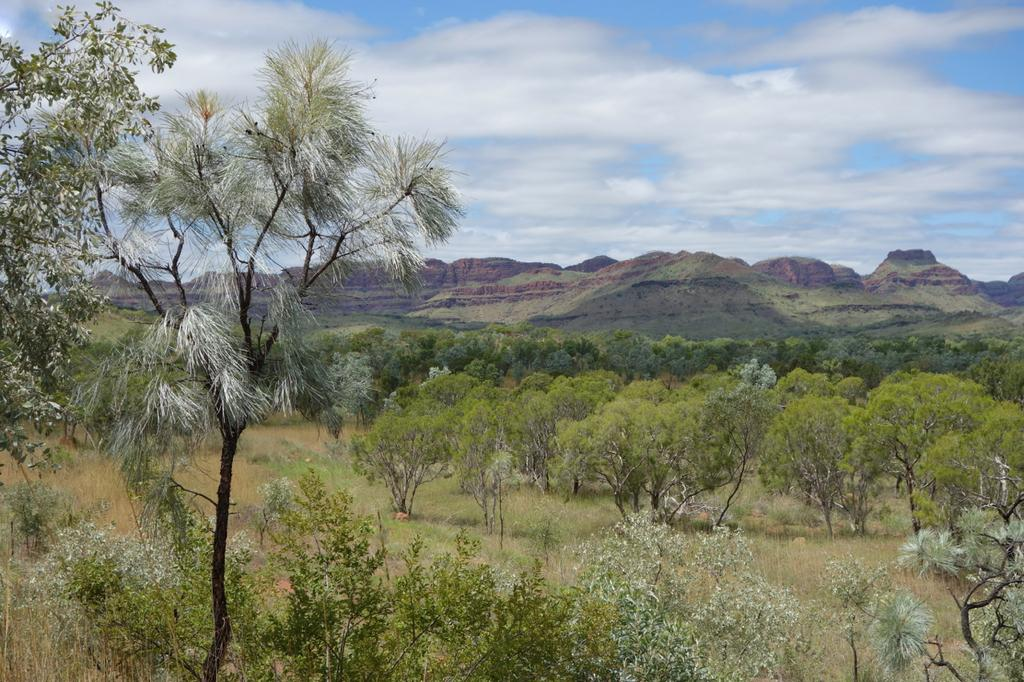What type of vegetation is present in the image? There is a group of trees and grass in the image. What can be seen in the distance in the image? Mountains are visible in the background of the image. What is the condition of the sky in the image? The sky is cloudy in the background of the image. What type of apple is being used to walk on the grass in the image? There is no apple or any indication of walking in the image; it features a group of trees, grass, mountains, and a cloudy sky. 